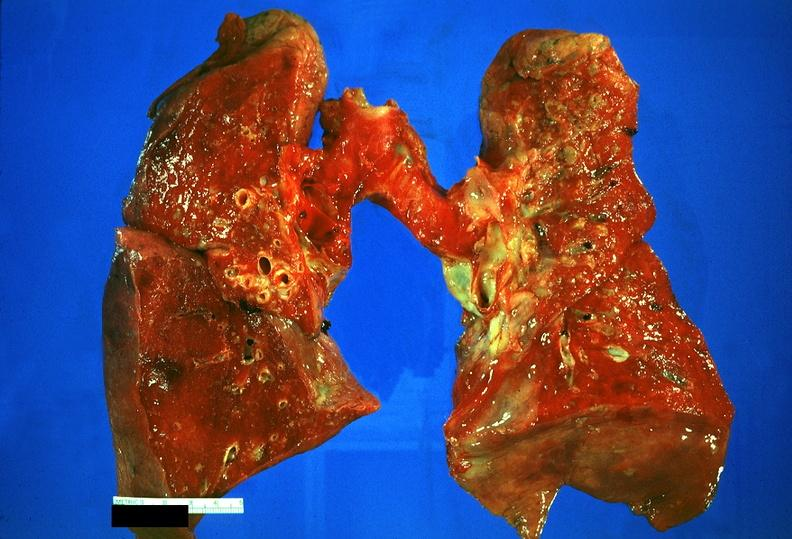where is this?
Answer the question using a single word or phrase. Lung 